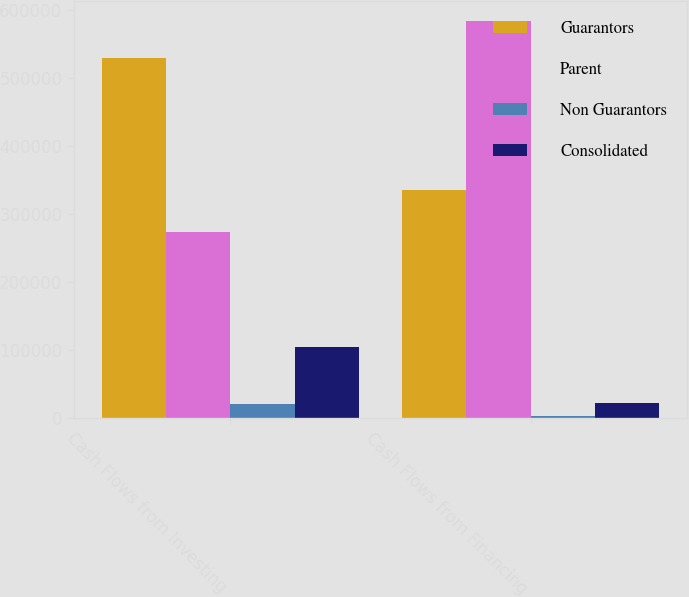Convert chart to OTSL. <chart><loc_0><loc_0><loc_500><loc_500><stacked_bar_chart><ecel><fcel>Cash Flows from Investing<fcel>Cash Flows from Financing<nl><fcel>Guarantors<fcel>530160<fcel>335663<nl><fcel>Parent<fcel>274003<fcel>584507<nl><fcel>Non Guarantors<fcel>20799<fcel>2382<nl><fcel>Consolidated<fcel>105221<fcel>21489<nl></chart> 